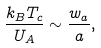<formula> <loc_0><loc_0><loc_500><loc_500>\frac { k _ { B } T _ { c } } { U _ { A } } \sim \frac { w _ { a } } { a } ,</formula> 